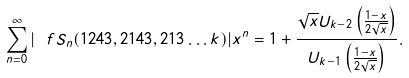<formula> <loc_0><loc_0><loc_500><loc_500>\sum _ { n = 0 } ^ { \infty } | \ f S _ { n } ( 1 2 4 3 , 2 1 4 3 , 2 1 3 \dots k ) | x ^ { n } = 1 + \frac { \sqrt { x } U _ { k - 2 } \left ( \frac { 1 - x } { 2 \sqrt { x } } \right ) } { U _ { k - 1 } \left ( \frac { 1 - x } { 2 \sqrt { x } } \right ) } .</formula> 